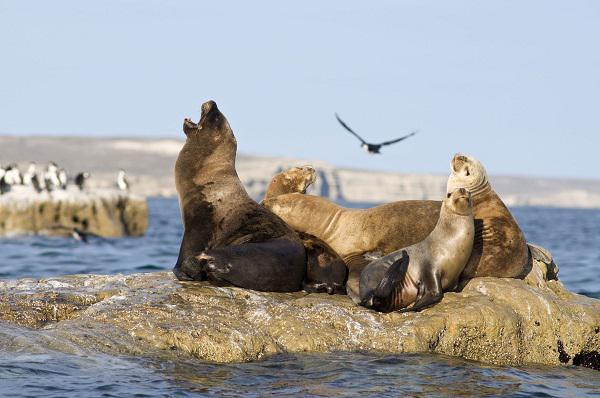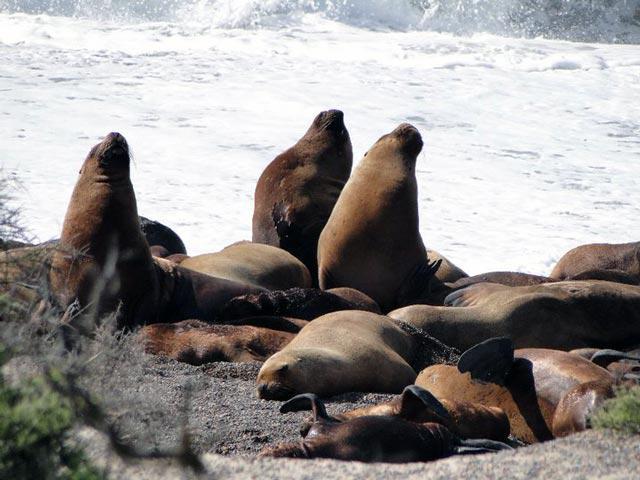The first image is the image on the left, the second image is the image on the right. Evaluate the accuracy of this statement regarding the images: "An image shows exactly two seals in direct contact, posed face to face.". Is it true? Answer yes or no. No. The first image is the image on the left, the second image is the image on the right. For the images displayed, is the sentence "The left image only has two seals." factually correct? Answer yes or no. No. 